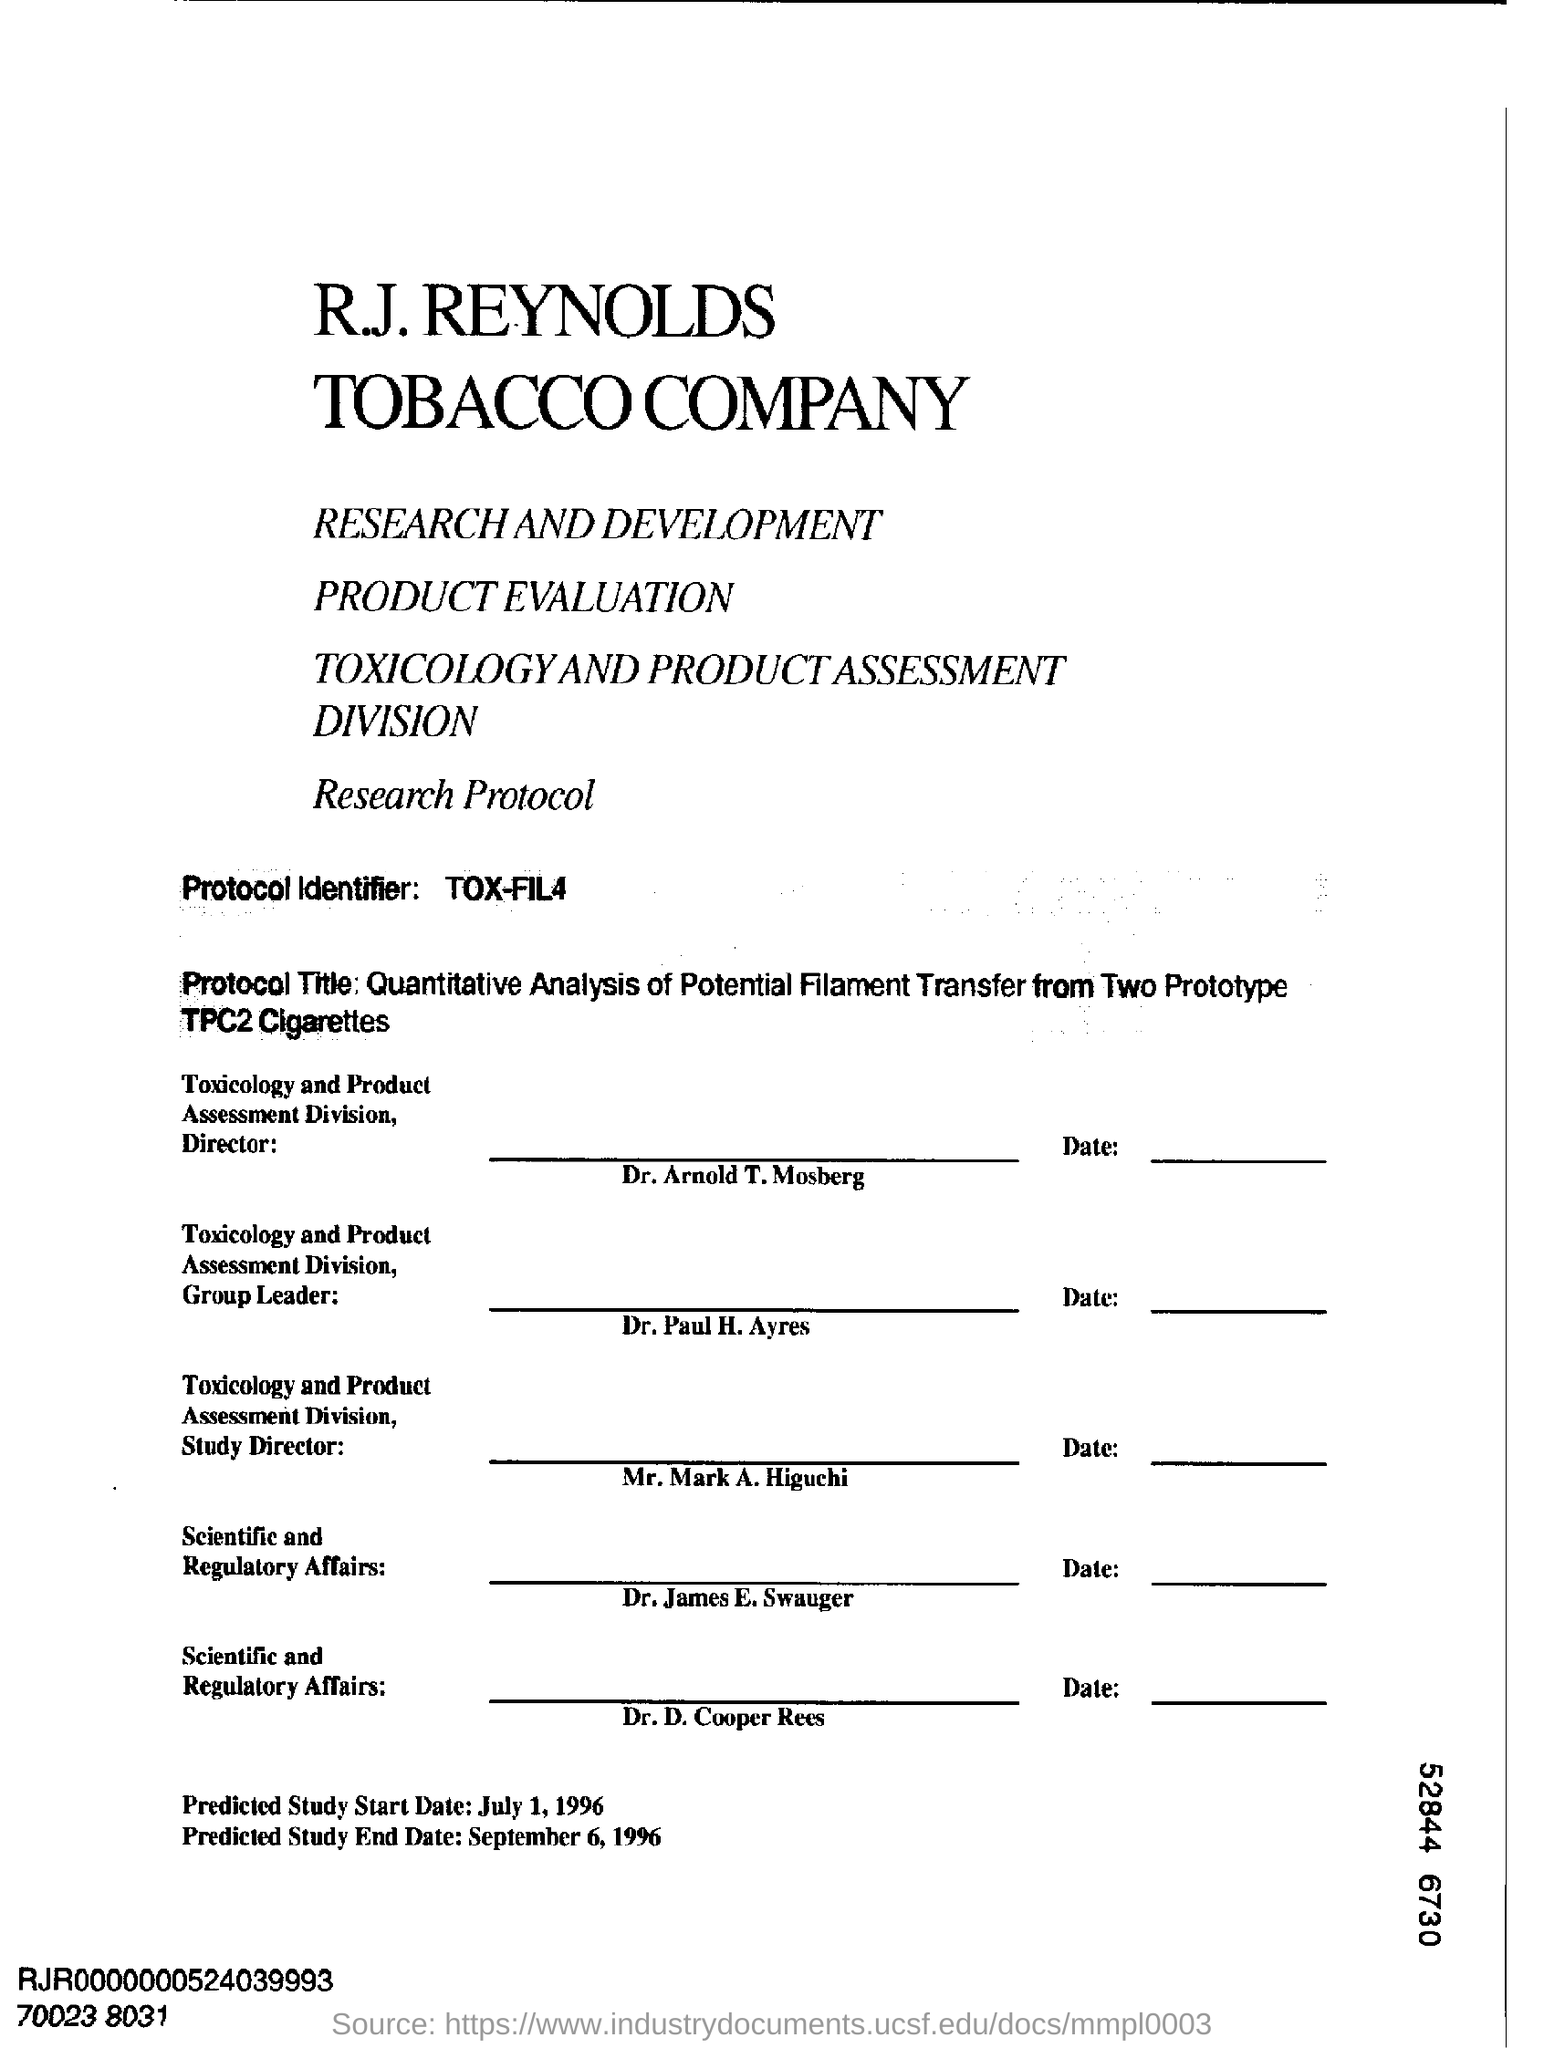Identify some key points in this picture. A protocol identifier is a string of characters that is used to identify a specific protocol or message within a communication system. The specific characters used in the identifier can vary, but they are typically unique to the protocol or message they are identifying. For example, the TOX-FIL4 protocol identifier might be used to identify a specific message or set of instructions within a communication system. The director of the Toxicology and Product Assessment division is Dr. Arnold T. Mosberg. The predicted start date of the study is July 1, 1996. 